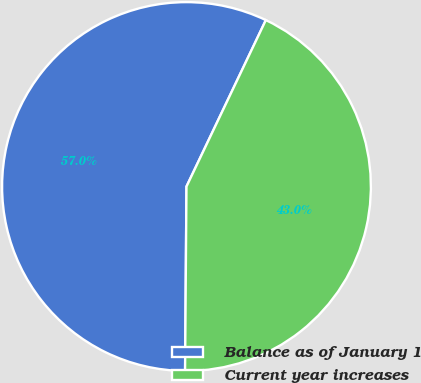Convert chart to OTSL. <chart><loc_0><loc_0><loc_500><loc_500><pie_chart><fcel>Balance as of January 1<fcel>Current year increases<nl><fcel>56.96%<fcel>43.04%<nl></chart> 